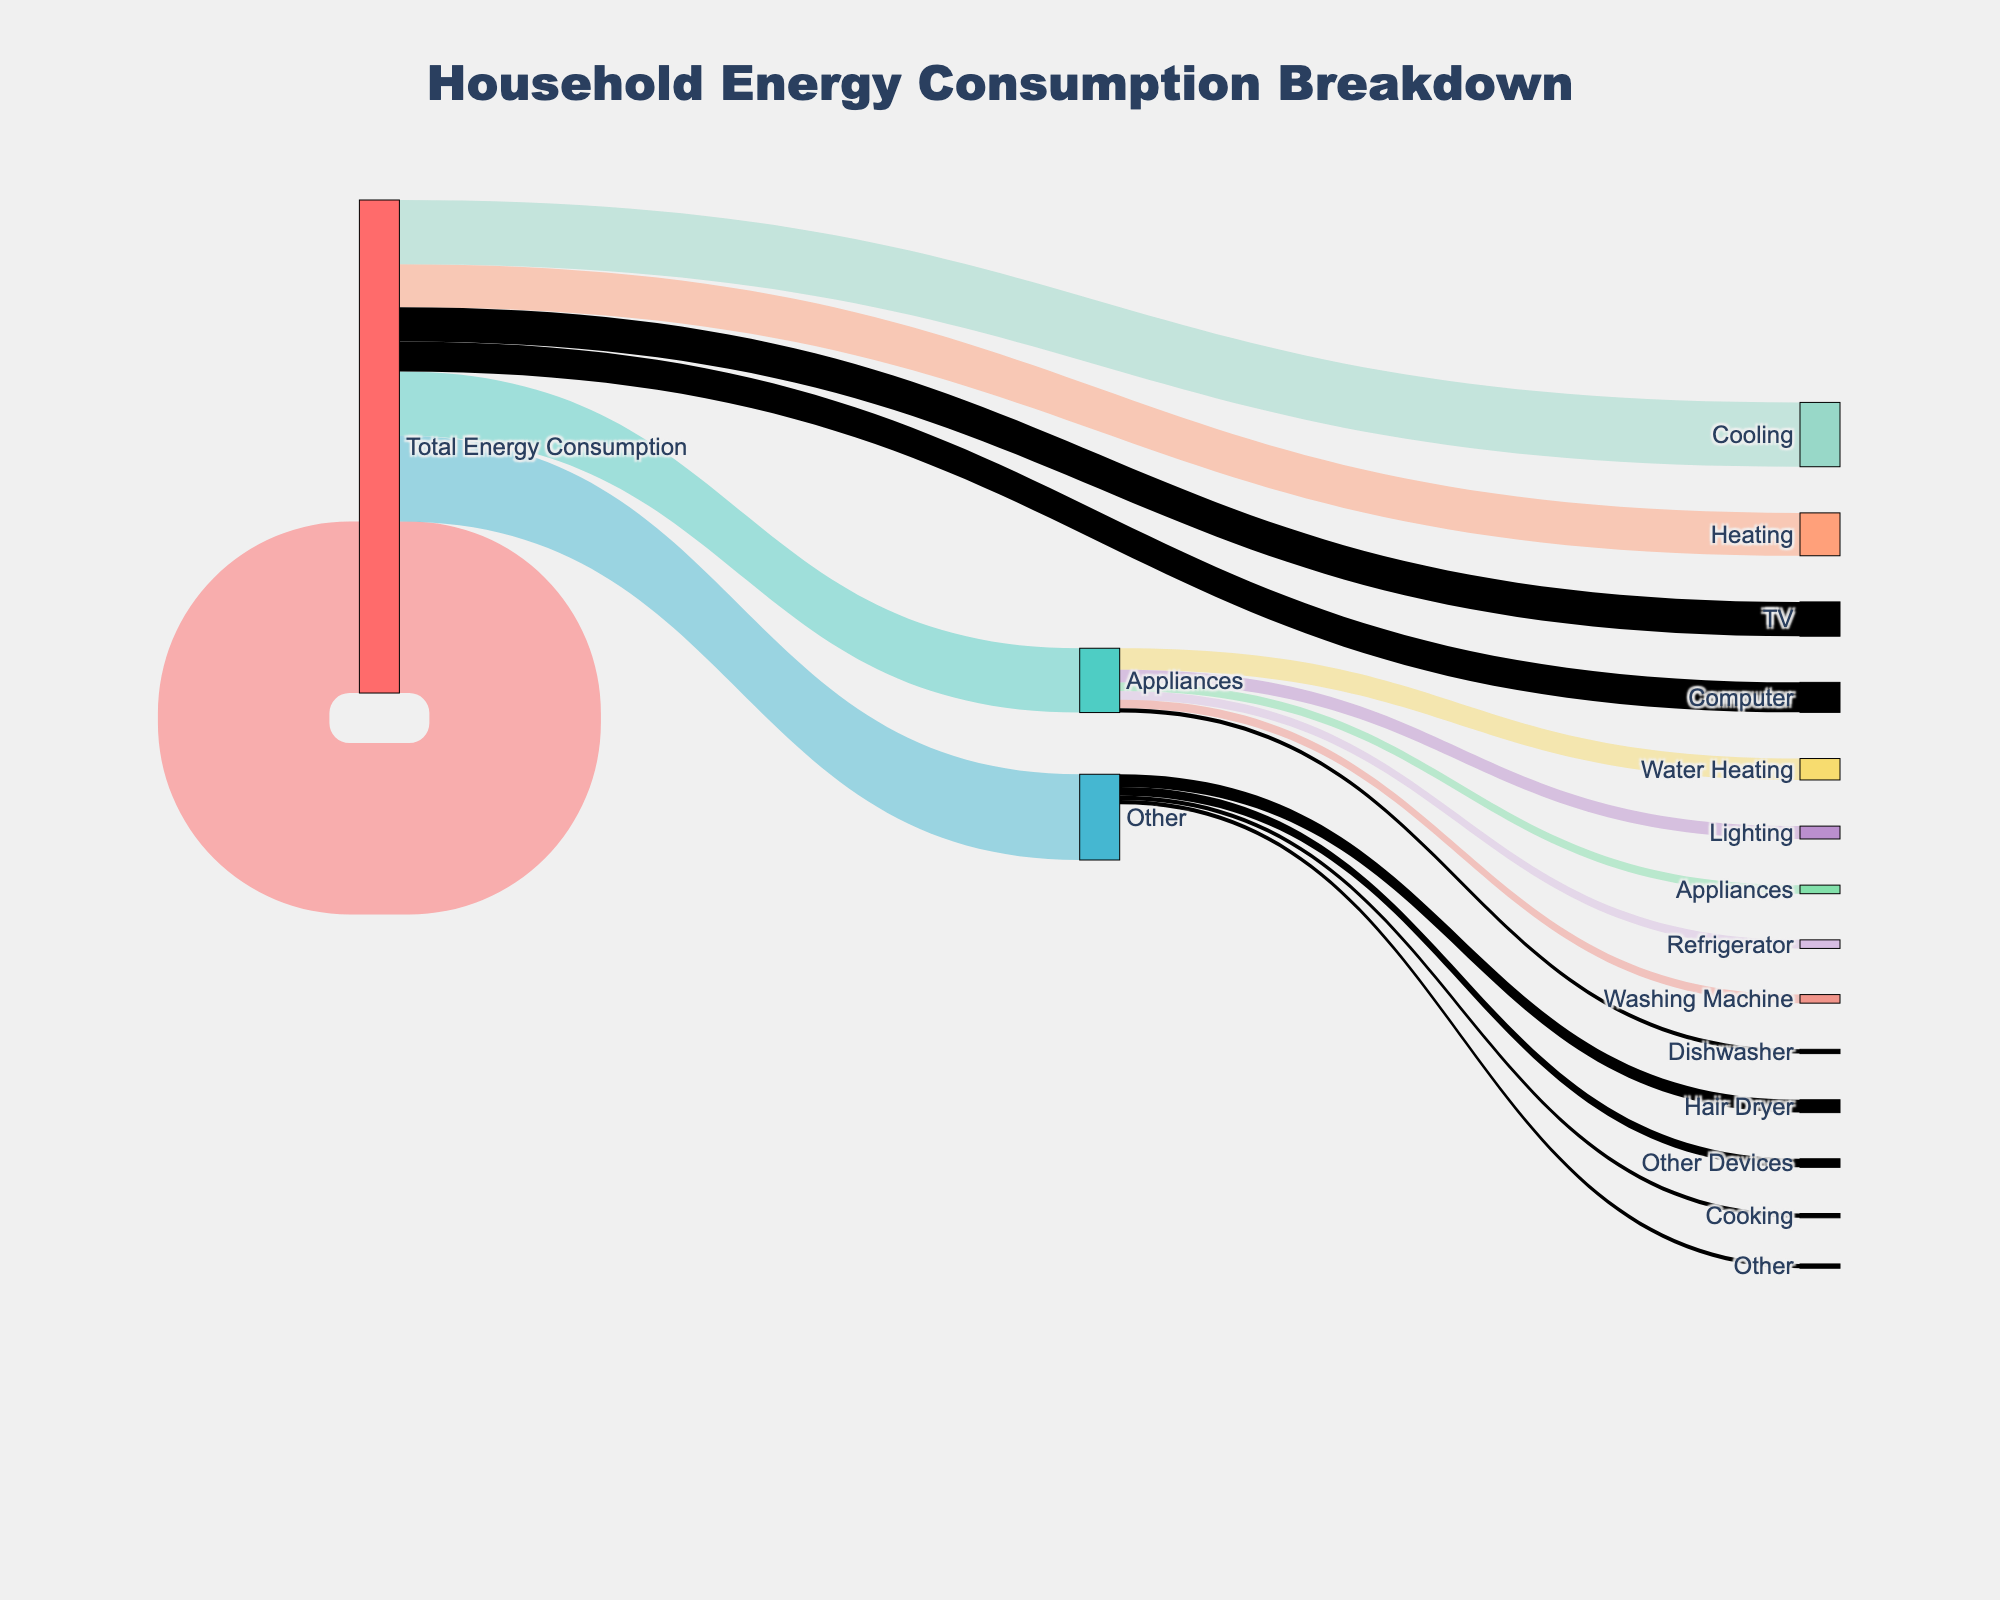What is the largest category in terms of household energy consumption? The largest category is the one with the highest value connected to "Total Energy Consumption." From the figure, Heating has a value of 40, which is the highest.
Answer: Heating How much total energy consumption is attributed to Appliances? The value connected to "Appliances" from "Total Energy Consumption" is shown directly on the Sankey diagram. It is 15.
Answer: 15 Which category uses more energy: Cooling or Lighting? From the Sankey diagram, Cooling has a value of 15, and Lighting has a value of 10. Cooling uses more energy.
Answer: Cooling What is the combined energy consumption of Other categories? To find this, we add up the values of Hair Dryer, Iron, Vacuum Cleaner, and Miscellaneous under "Other." 2 + 1 + 1 + 3 = 7.
Answer: 7 How does the energy consumption of Cooking compare to that of Water Heating? The value for Cooking is 8, while for Water Heating, it is 20. Water Heating has more energy consumption than Cooking.
Answer: Water Heating What appliance under "Appliances" consumes the most energy? Under "Appliances," the diagram shows that the Refrigerator has the largest value of 5.
Answer: Refrigerator How is the "Other" category broken down by individual activities? The "Other" category is broken down into Hair Dryer (2), Iron (1), Vacuum Cleaner (1), and Miscellaneous (3).
Answer: Hair Dryer, Iron, Vacuum Cleaner, Miscellaneous What is the total energy consumption of Washing Machine and Dishwasher combined? The values are 3 for Washing Machine and 2 for Dishwasher. Their combined energy consumption is 3 + 2 = 5.
Answer: 5 Which consumes less energy: TV or Computer? Both TV and Computer have the same value of 2 for their energy consumption, so they consume equal energy.
Answer: Equal What is the total energy consumption for Heating, Cooling, and Lighting combined? The values are Heating (40), Cooling (15), and Lighting (10). Their total energy consumption is 40 + 15 + 10 = 65.
Answer: 65 